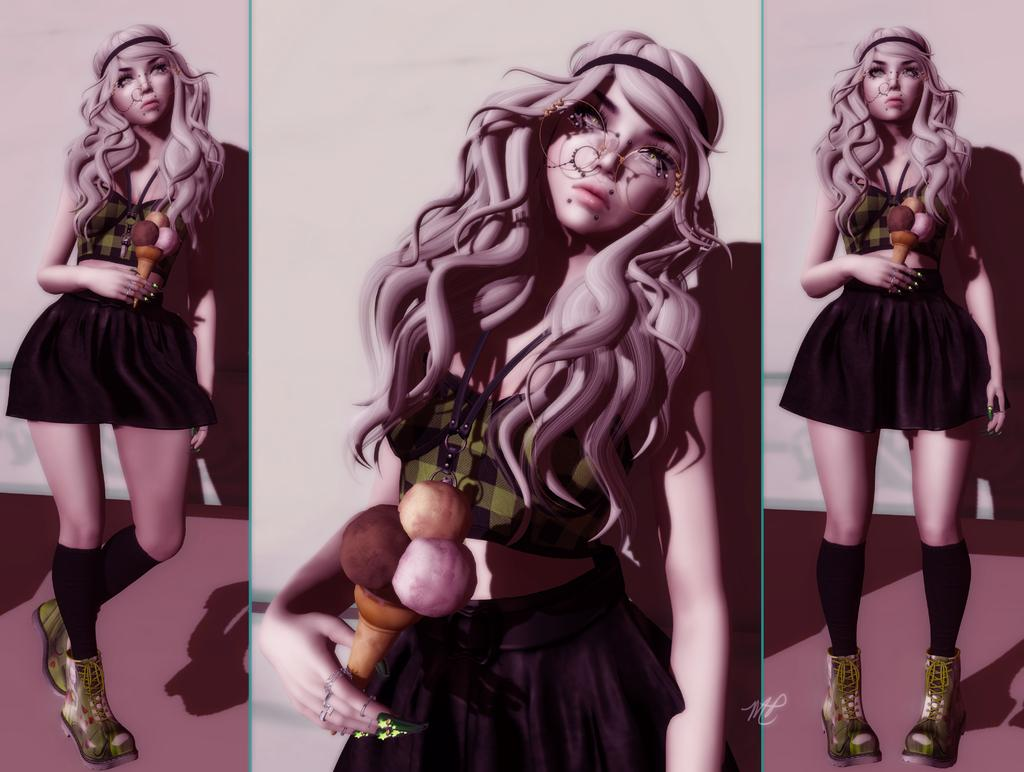Who is present in the image? There is a woman in the image. What is the woman holding in the image? The woman is holding an ice cream. What can be seen in the background of the image? There is a wall in the background of the image. What type of bushes can be seen growing near the wall in the image? There are no bushes visible in the image; only a wall is present in the background. 